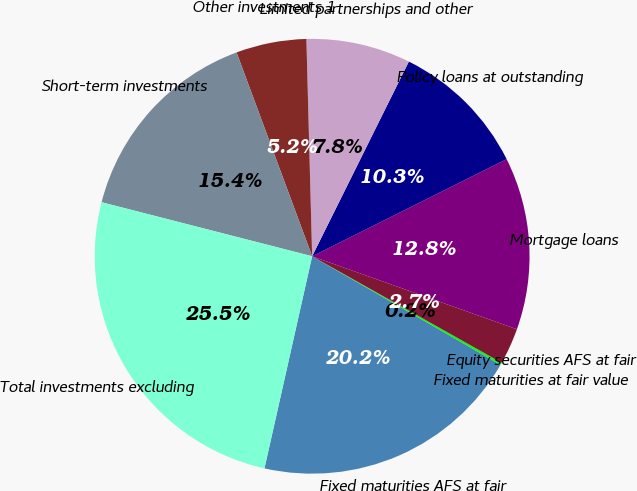Convert chart. <chart><loc_0><loc_0><loc_500><loc_500><pie_chart><fcel>Fixed maturities AFS at fair<fcel>Fixed maturities at fair value<fcel>Equity securities AFS at fair<fcel>Mortgage loans<fcel>Policy loans at outstanding<fcel>Limited partnerships and other<fcel>Other investments 1<fcel>Short-term investments<fcel>Total investments excluding<nl><fcel>20.2%<fcel>0.17%<fcel>2.7%<fcel>12.82%<fcel>10.29%<fcel>7.76%<fcel>5.23%<fcel>15.35%<fcel>25.48%<nl></chart> 